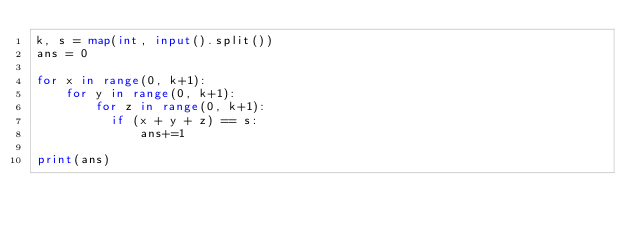<code> <loc_0><loc_0><loc_500><loc_500><_Python_>k, s = map(int, input().split())
ans = 0

for x in range(0, k+1):
    for y in range(0, k+1):
        for z in range(0, k+1):
          if (x + y + z) == s:
              ans+=1

print(ans)
</code> 